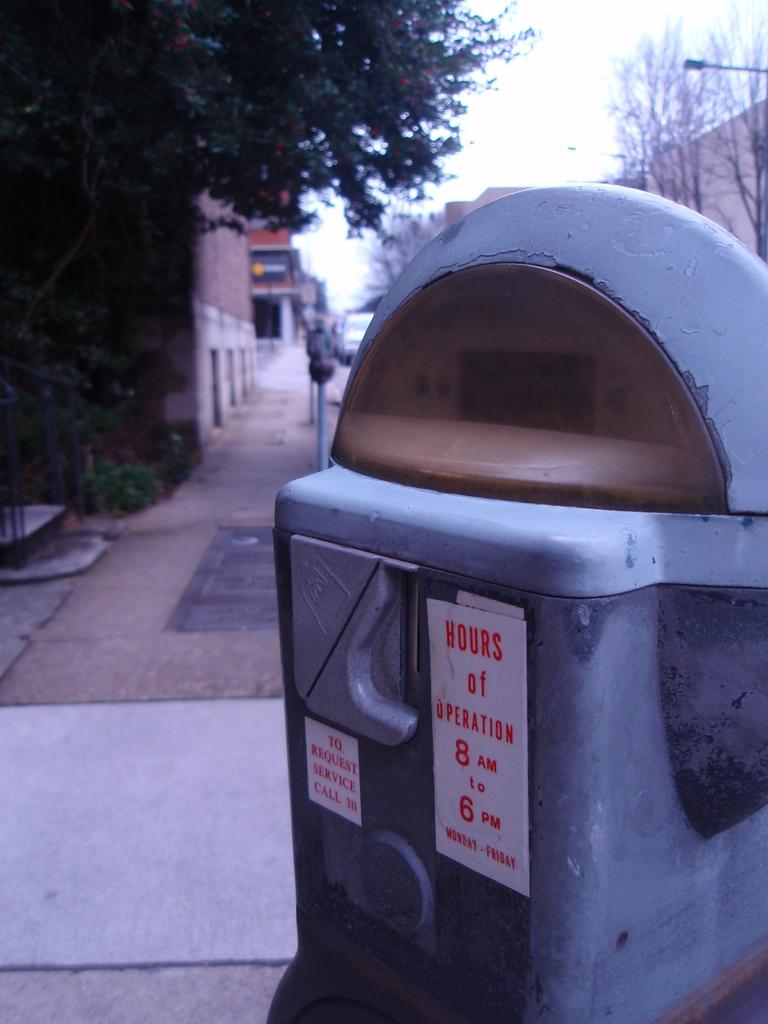<image>
Relay a brief, clear account of the picture shown. A parking meter has a white sticker that says Hours of Operation in red letters. 